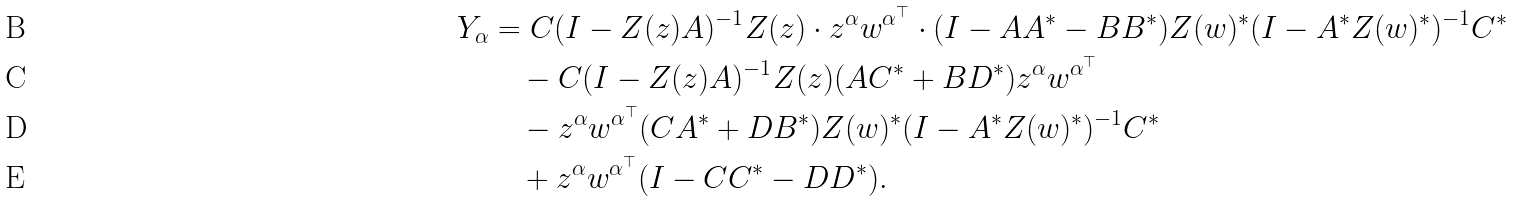<formula> <loc_0><loc_0><loc_500><loc_500>Y _ { \alpha } & = C ( I - Z ( z ) A ) ^ { - 1 } Z ( z ) \cdot z ^ { \alpha } w ^ { \alpha ^ { \top } } \cdot ( I - A A ^ { * } - B B ^ { * } ) Z ( w ) ^ { * } ( I - A ^ { * } Z ( w ) ^ { * } ) ^ { - 1 } C ^ { * } \\ & \quad - C ( I - Z ( z ) A ) ^ { - 1 } Z ( z ) ( A C ^ { * } + B D ^ { * } ) z ^ { \alpha } w ^ { \alpha ^ { \top } } \\ & \quad - z ^ { \alpha } w ^ { \alpha ^ { \top } } ( C A ^ { * } + D B ^ { * } ) Z ( w ) ^ { * } ( I - A ^ { * } Z ( w ) ^ { * } ) ^ { - 1 } C ^ { * } \\ & \quad + z ^ { \alpha } w ^ { \alpha ^ { \top } } ( I - C C ^ { * } - D D ^ { * } ) .</formula> 